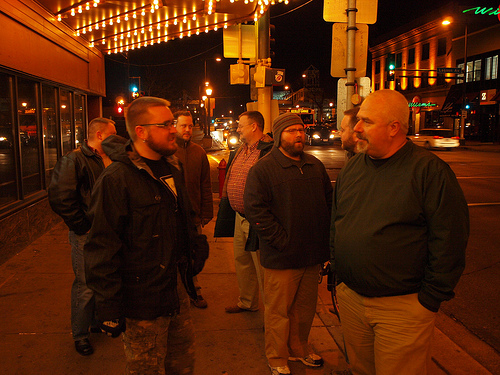<image>
Is there a ground under the light? Yes. The ground is positioned underneath the light, with the light above it in the vertical space. 